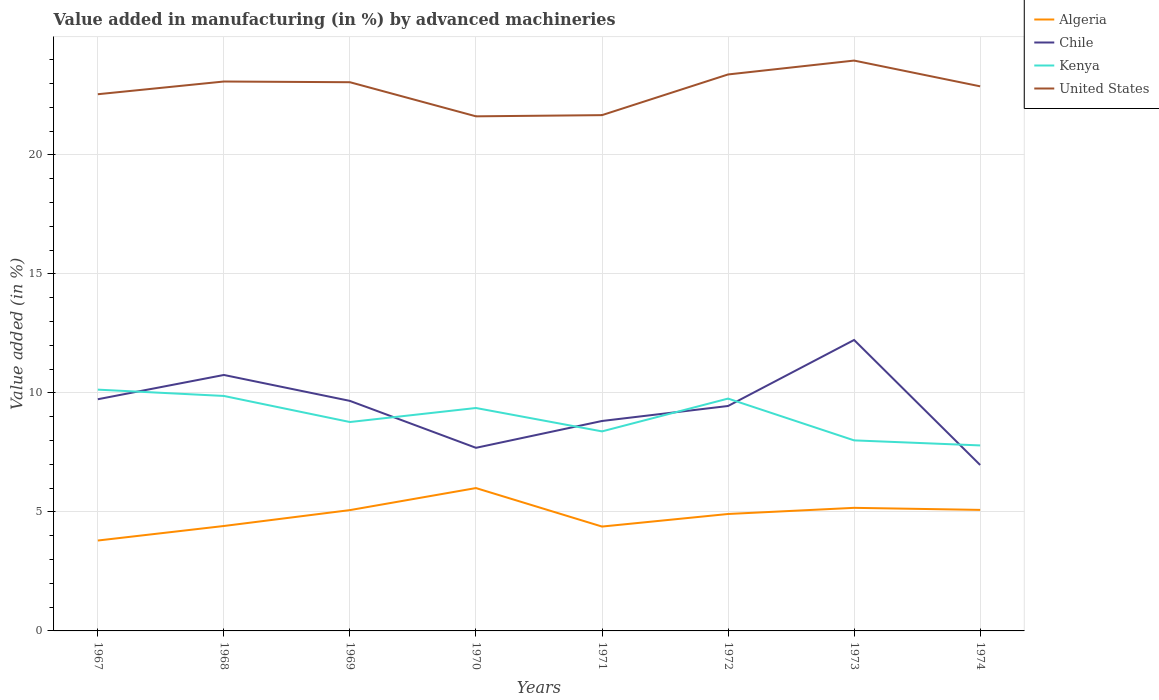How many different coloured lines are there?
Provide a short and direct response. 4. Does the line corresponding to Algeria intersect with the line corresponding to Chile?
Offer a very short reply. No. Across all years, what is the maximum percentage of value added in manufacturing by advanced machineries in United States?
Provide a short and direct response. 21.62. In which year was the percentage of value added in manufacturing by advanced machineries in Kenya maximum?
Provide a short and direct response. 1974. What is the total percentage of value added in manufacturing by advanced machineries in Algeria in the graph?
Make the answer very short. 0.83. What is the difference between the highest and the second highest percentage of value added in manufacturing by advanced machineries in Kenya?
Ensure brevity in your answer.  2.34. How many years are there in the graph?
Your answer should be very brief. 8. What is the difference between two consecutive major ticks on the Y-axis?
Ensure brevity in your answer.  5. Are the values on the major ticks of Y-axis written in scientific E-notation?
Give a very brief answer. No. Does the graph contain any zero values?
Your response must be concise. No. Does the graph contain grids?
Provide a succinct answer. Yes. Where does the legend appear in the graph?
Give a very brief answer. Top right. How many legend labels are there?
Your answer should be very brief. 4. What is the title of the graph?
Ensure brevity in your answer.  Value added in manufacturing (in %) by advanced machineries. Does "Luxembourg" appear as one of the legend labels in the graph?
Provide a short and direct response. No. What is the label or title of the X-axis?
Provide a succinct answer. Years. What is the label or title of the Y-axis?
Offer a terse response. Value added (in %). What is the Value added (in %) of Algeria in 1967?
Ensure brevity in your answer.  3.8. What is the Value added (in %) in Chile in 1967?
Make the answer very short. 9.73. What is the Value added (in %) of Kenya in 1967?
Provide a short and direct response. 10.14. What is the Value added (in %) of United States in 1967?
Provide a succinct answer. 22.55. What is the Value added (in %) in Algeria in 1968?
Keep it short and to the point. 4.41. What is the Value added (in %) of Chile in 1968?
Provide a succinct answer. 10.75. What is the Value added (in %) in Kenya in 1968?
Offer a very short reply. 9.87. What is the Value added (in %) of United States in 1968?
Offer a very short reply. 23.08. What is the Value added (in %) of Algeria in 1969?
Ensure brevity in your answer.  5.08. What is the Value added (in %) in Chile in 1969?
Offer a terse response. 9.66. What is the Value added (in %) in Kenya in 1969?
Your answer should be very brief. 8.78. What is the Value added (in %) in United States in 1969?
Provide a succinct answer. 23.05. What is the Value added (in %) in Algeria in 1970?
Provide a short and direct response. 6. What is the Value added (in %) of Chile in 1970?
Provide a succinct answer. 7.69. What is the Value added (in %) in Kenya in 1970?
Make the answer very short. 9.37. What is the Value added (in %) in United States in 1970?
Ensure brevity in your answer.  21.62. What is the Value added (in %) in Algeria in 1971?
Make the answer very short. 4.38. What is the Value added (in %) of Chile in 1971?
Offer a very short reply. 8.82. What is the Value added (in %) in Kenya in 1971?
Make the answer very short. 8.38. What is the Value added (in %) in United States in 1971?
Provide a succinct answer. 21.67. What is the Value added (in %) in Algeria in 1972?
Offer a terse response. 4.91. What is the Value added (in %) in Chile in 1972?
Provide a short and direct response. 9.45. What is the Value added (in %) of Kenya in 1972?
Your answer should be very brief. 9.76. What is the Value added (in %) of United States in 1972?
Provide a short and direct response. 23.38. What is the Value added (in %) of Algeria in 1973?
Offer a very short reply. 5.17. What is the Value added (in %) in Chile in 1973?
Provide a short and direct response. 12.22. What is the Value added (in %) in Kenya in 1973?
Offer a terse response. 8. What is the Value added (in %) of United States in 1973?
Your answer should be compact. 23.96. What is the Value added (in %) of Algeria in 1974?
Your answer should be very brief. 5.08. What is the Value added (in %) in Chile in 1974?
Offer a terse response. 6.97. What is the Value added (in %) in Kenya in 1974?
Ensure brevity in your answer.  7.79. What is the Value added (in %) of United States in 1974?
Your answer should be compact. 22.88. Across all years, what is the maximum Value added (in %) of Algeria?
Keep it short and to the point. 6. Across all years, what is the maximum Value added (in %) in Chile?
Keep it short and to the point. 12.22. Across all years, what is the maximum Value added (in %) of Kenya?
Give a very brief answer. 10.14. Across all years, what is the maximum Value added (in %) in United States?
Provide a succinct answer. 23.96. Across all years, what is the minimum Value added (in %) in Algeria?
Give a very brief answer. 3.8. Across all years, what is the minimum Value added (in %) of Chile?
Keep it short and to the point. 6.97. Across all years, what is the minimum Value added (in %) in Kenya?
Offer a terse response. 7.79. Across all years, what is the minimum Value added (in %) of United States?
Offer a terse response. 21.62. What is the total Value added (in %) in Algeria in the graph?
Provide a succinct answer. 38.83. What is the total Value added (in %) of Chile in the graph?
Your response must be concise. 75.3. What is the total Value added (in %) of Kenya in the graph?
Your answer should be very brief. 72.09. What is the total Value added (in %) of United States in the graph?
Ensure brevity in your answer.  182.18. What is the difference between the Value added (in %) of Algeria in 1967 and that in 1968?
Your answer should be compact. -0.61. What is the difference between the Value added (in %) in Chile in 1967 and that in 1968?
Provide a short and direct response. -1.02. What is the difference between the Value added (in %) of Kenya in 1967 and that in 1968?
Your response must be concise. 0.27. What is the difference between the Value added (in %) in United States in 1967 and that in 1968?
Give a very brief answer. -0.53. What is the difference between the Value added (in %) of Algeria in 1967 and that in 1969?
Your answer should be very brief. -1.28. What is the difference between the Value added (in %) in Chile in 1967 and that in 1969?
Provide a succinct answer. 0.07. What is the difference between the Value added (in %) of Kenya in 1967 and that in 1969?
Your answer should be very brief. 1.36. What is the difference between the Value added (in %) in United States in 1967 and that in 1969?
Offer a very short reply. -0.5. What is the difference between the Value added (in %) in Algeria in 1967 and that in 1970?
Offer a very short reply. -2.2. What is the difference between the Value added (in %) in Chile in 1967 and that in 1970?
Your answer should be very brief. 2.04. What is the difference between the Value added (in %) in Kenya in 1967 and that in 1970?
Give a very brief answer. 0.77. What is the difference between the Value added (in %) of United States in 1967 and that in 1970?
Your answer should be compact. 0.93. What is the difference between the Value added (in %) of Algeria in 1967 and that in 1971?
Your answer should be very brief. -0.59. What is the difference between the Value added (in %) of Chile in 1967 and that in 1971?
Give a very brief answer. 0.91. What is the difference between the Value added (in %) of Kenya in 1967 and that in 1971?
Offer a very short reply. 1.75. What is the difference between the Value added (in %) of United States in 1967 and that in 1971?
Ensure brevity in your answer.  0.88. What is the difference between the Value added (in %) of Algeria in 1967 and that in 1972?
Your answer should be very brief. -1.11. What is the difference between the Value added (in %) in Chile in 1967 and that in 1972?
Your answer should be very brief. 0.28. What is the difference between the Value added (in %) of Kenya in 1967 and that in 1972?
Keep it short and to the point. 0.38. What is the difference between the Value added (in %) of United States in 1967 and that in 1972?
Provide a succinct answer. -0.83. What is the difference between the Value added (in %) in Algeria in 1967 and that in 1973?
Provide a short and direct response. -1.37. What is the difference between the Value added (in %) of Chile in 1967 and that in 1973?
Provide a short and direct response. -2.49. What is the difference between the Value added (in %) of Kenya in 1967 and that in 1973?
Your answer should be compact. 2.13. What is the difference between the Value added (in %) in United States in 1967 and that in 1973?
Offer a very short reply. -1.41. What is the difference between the Value added (in %) of Algeria in 1967 and that in 1974?
Keep it short and to the point. -1.29. What is the difference between the Value added (in %) in Chile in 1967 and that in 1974?
Give a very brief answer. 2.76. What is the difference between the Value added (in %) in Kenya in 1967 and that in 1974?
Your response must be concise. 2.34. What is the difference between the Value added (in %) in United States in 1967 and that in 1974?
Keep it short and to the point. -0.33. What is the difference between the Value added (in %) in Algeria in 1968 and that in 1969?
Ensure brevity in your answer.  -0.67. What is the difference between the Value added (in %) in Chile in 1968 and that in 1969?
Ensure brevity in your answer.  1.09. What is the difference between the Value added (in %) in Kenya in 1968 and that in 1969?
Your response must be concise. 1.1. What is the difference between the Value added (in %) of United States in 1968 and that in 1969?
Make the answer very short. 0.03. What is the difference between the Value added (in %) in Algeria in 1968 and that in 1970?
Your answer should be very brief. -1.59. What is the difference between the Value added (in %) of Chile in 1968 and that in 1970?
Offer a very short reply. 3.06. What is the difference between the Value added (in %) of Kenya in 1968 and that in 1970?
Your answer should be very brief. 0.51. What is the difference between the Value added (in %) of United States in 1968 and that in 1970?
Your response must be concise. 1.46. What is the difference between the Value added (in %) in Algeria in 1968 and that in 1971?
Give a very brief answer. 0.02. What is the difference between the Value added (in %) in Chile in 1968 and that in 1971?
Give a very brief answer. 1.93. What is the difference between the Value added (in %) of Kenya in 1968 and that in 1971?
Offer a very short reply. 1.49. What is the difference between the Value added (in %) in United States in 1968 and that in 1971?
Your answer should be very brief. 1.41. What is the difference between the Value added (in %) in Algeria in 1968 and that in 1972?
Offer a terse response. -0.5. What is the difference between the Value added (in %) of Chile in 1968 and that in 1972?
Your answer should be very brief. 1.3. What is the difference between the Value added (in %) of Kenya in 1968 and that in 1972?
Your response must be concise. 0.11. What is the difference between the Value added (in %) in United States in 1968 and that in 1972?
Provide a succinct answer. -0.3. What is the difference between the Value added (in %) in Algeria in 1968 and that in 1973?
Offer a very short reply. -0.76. What is the difference between the Value added (in %) of Chile in 1968 and that in 1973?
Give a very brief answer. -1.47. What is the difference between the Value added (in %) in Kenya in 1968 and that in 1973?
Offer a very short reply. 1.87. What is the difference between the Value added (in %) in United States in 1968 and that in 1973?
Your answer should be compact. -0.88. What is the difference between the Value added (in %) of Algeria in 1968 and that in 1974?
Offer a terse response. -0.68. What is the difference between the Value added (in %) of Chile in 1968 and that in 1974?
Ensure brevity in your answer.  3.78. What is the difference between the Value added (in %) of Kenya in 1968 and that in 1974?
Give a very brief answer. 2.08. What is the difference between the Value added (in %) of United States in 1968 and that in 1974?
Offer a very short reply. 0.2. What is the difference between the Value added (in %) of Algeria in 1969 and that in 1970?
Offer a very short reply. -0.93. What is the difference between the Value added (in %) in Chile in 1969 and that in 1970?
Give a very brief answer. 1.97. What is the difference between the Value added (in %) in Kenya in 1969 and that in 1970?
Your response must be concise. -0.59. What is the difference between the Value added (in %) of United States in 1969 and that in 1970?
Provide a succinct answer. 1.43. What is the difference between the Value added (in %) of Algeria in 1969 and that in 1971?
Your answer should be very brief. 0.69. What is the difference between the Value added (in %) in Chile in 1969 and that in 1971?
Keep it short and to the point. 0.84. What is the difference between the Value added (in %) in Kenya in 1969 and that in 1971?
Your answer should be very brief. 0.39. What is the difference between the Value added (in %) of United States in 1969 and that in 1971?
Offer a very short reply. 1.38. What is the difference between the Value added (in %) in Algeria in 1969 and that in 1972?
Offer a very short reply. 0.16. What is the difference between the Value added (in %) in Chile in 1969 and that in 1972?
Your answer should be compact. 0.21. What is the difference between the Value added (in %) in Kenya in 1969 and that in 1972?
Your response must be concise. -0.98. What is the difference between the Value added (in %) in United States in 1969 and that in 1972?
Your response must be concise. -0.33. What is the difference between the Value added (in %) of Algeria in 1969 and that in 1973?
Keep it short and to the point. -0.1. What is the difference between the Value added (in %) of Chile in 1969 and that in 1973?
Make the answer very short. -2.56. What is the difference between the Value added (in %) in Kenya in 1969 and that in 1973?
Offer a terse response. 0.77. What is the difference between the Value added (in %) of United States in 1969 and that in 1973?
Offer a terse response. -0.91. What is the difference between the Value added (in %) of Algeria in 1969 and that in 1974?
Make the answer very short. -0.01. What is the difference between the Value added (in %) of Chile in 1969 and that in 1974?
Offer a very short reply. 2.69. What is the difference between the Value added (in %) in Kenya in 1969 and that in 1974?
Your answer should be compact. 0.98. What is the difference between the Value added (in %) in United States in 1969 and that in 1974?
Your answer should be compact. 0.17. What is the difference between the Value added (in %) of Algeria in 1970 and that in 1971?
Ensure brevity in your answer.  1.62. What is the difference between the Value added (in %) in Chile in 1970 and that in 1971?
Your response must be concise. -1.13. What is the difference between the Value added (in %) in Kenya in 1970 and that in 1971?
Offer a terse response. 0.98. What is the difference between the Value added (in %) in United States in 1970 and that in 1971?
Your answer should be very brief. -0.05. What is the difference between the Value added (in %) of Algeria in 1970 and that in 1972?
Offer a very short reply. 1.09. What is the difference between the Value added (in %) in Chile in 1970 and that in 1972?
Make the answer very short. -1.76. What is the difference between the Value added (in %) of Kenya in 1970 and that in 1972?
Your answer should be compact. -0.4. What is the difference between the Value added (in %) in United States in 1970 and that in 1972?
Your answer should be compact. -1.76. What is the difference between the Value added (in %) of Algeria in 1970 and that in 1973?
Provide a short and direct response. 0.83. What is the difference between the Value added (in %) in Chile in 1970 and that in 1973?
Make the answer very short. -4.53. What is the difference between the Value added (in %) of Kenya in 1970 and that in 1973?
Your response must be concise. 1.36. What is the difference between the Value added (in %) in United States in 1970 and that in 1973?
Provide a succinct answer. -2.34. What is the difference between the Value added (in %) in Algeria in 1970 and that in 1974?
Provide a succinct answer. 0.92. What is the difference between the Value added (in %) in Chile in 1970 and that in 1974?
Provide a succinct answer. 0.72. What is the difference between the Value added (in %) in Kenya in 1970 and that in 1974?
Provide a short and direct response. 1.57. What is the difference between the Value added (in %) in United States in 1970 and that in 1974?
Your answer should be very brief. -1.26. What is the difference between the Value added (in %) in Algeria in 1971 and that in 1972?
Provide a short and direct response. -0.53. What is the difference between the Value added (in %) in Chile in 1971 and that in 1972?
Offer a very short reply. -0.63. What is the difference between the Value added (in %) of Kenya in 1971 and that in 1972?
Offer a terse response. -1.38. What is the difference between the Value added (in %) of United States in 1971 and that in 1972?
Offer a terse response. -1.71. What is the difference between the Value added (in %) in Algeria in 1971 and that in 1973?
Your answer should be very brief. -0.79. What is the difference between the Value added (in %) of Chile in 1971 and that in 1973?
Offer a terse response. -3.4. What is the difference between the Value added (in %) in Kenya in 1971 and that in 1973?
Provide a succinct answer. 0.38. What is the difference between the Value added (in %) of United States in 1971 and that in 1973?
Your response must be concise. -2.29. What is the difference between the Value added (in %) in Algeria in 1971 and that in 1974?
Ensure brevity in your answer.  -0.7. What is the difference between the Value added (in %) of Chile in 1971 and that in 1974?
Offer a very short reply. 1.85. What is the difference between the Value added (in %) of Kenya in 1971 and that in 1974?
Give a very brief answer. 0.59. What is the difference between the Value added (in %) of United States in 1971 and that in 1974?
Provide a short and direct response. -1.21. What is the difference between the Value added (in %) in Algeria in 1972 and that in 1973?
Your answer should be compact. -0.26. What is the difference between the Value added (in %) of Chile in 1972 and that in 1973?
Your response must be concise. -2.77. What is the difference between the Value added (in %) in Kenya in 1972 and that in 1973?
Your answer should be very brief. 1.76. What is the difference between the Value added (in %) of United States in 1972 and that in 1973?
Make the answer very short. -0.58. What is the difference between the Value added (in %) of Algeria in 1972 and that in 1974?
Your response must be concise. -0.17. What is the difference between the Value added (in %) of Chile in 1972 and that in 1974?
Offer a very short reply. 2.48. What is the difference between the Value added (in %) in Kenya in 1972 and that in 1974?
Provide a succinct answer. 1.97. What is the difference between the Value added (in %) in United States in 1972 and that in 1974?
Your answer should be very brief. 0.5. What is the difference between the Value added (in %) of Algeria in 1973 and that in 1974?
Provide a short and direct response. 0.09. What is the difference between the Value added (in %) of Chile in 1973 and that in 1974?
Give a very brief answer. 5.25. What is the difference between the Value added (in %) in Kenya in 1973 and that in 1974?
Provide a succinct answer. 0.21. What is the difference between the Value added (in %) of United States in 1973 and that in 1974?
Ensure brevity in your answer.  1.08. What is the difference between the Value added (in %) of Algeria in 1967 and the Value added (in %) of Chile in 1968?
Offer a very short reply. -6.96. What is the difference between the Value added (in %) of Algeria in 1967 and the Value added (in %) of Kenya in 1968?
Make the answer very short. -6.07. What is the difference between the Value added (in %) of Algeria in 1967 and the Value added (in %) of United States in 1968?
Offer a terse response. -19.28. What is the difference between the Value added (in %) in Chile in 1967 and the Value added (in %) in Kenya in 1968?
Ensure brevity in your answer.  -0.14. What is the difference between the Value added (in %) of Chile in 1967 and the Value added (in %) of United States in 1968?
Offer a terse response. -13.35. What is the difference between the Value added (in %) of Kenya in 1967 and the Value added (in %) of United States in 1968?
Your answer should be very brief. -12.94. What is the difference between the Value added (in %) of Algeria in 1967 and the Value added (in %) of Chile in 1969?
Offer a very short reply. -5.87. What is the difference between the Value added (in %) of Algeria in 1967 and the Value added (in %) of Kenya in 1969?
Make the answer very short. -4.98. What is the difference between the Value added (in %) in Algeria in 1967 and the Value added (in %) in United States in 1969?
Offer a terse response. -19.25. What is the difference between the Value added (in %) of Chile in 1967 and the Value added (in %) of Kenya in 1969?
Give a very brief answer. 0.96. What is the difference between the Value added (in %) of Chile in 1967 and the Value added (in %) of United States in 1969?
Your response must be concise. -13.32. What is the difference between the Value added (in %) of Kenya in 1967 and the Value added (in %) of United States in 1969?
Offer a terse response. -12.91. What is the difference between the Value added (in %) in Algeria in 1967 and the Value added (in %) in Chile in 1970?
Offer a very short reply. -3.89. What is the difference between the Value added (in %) in Algeria in 1967 and the Value added (in %) in Kenya in 1970?
Your response must be concise. -5.57. What is the difference between the Value added (in %) of Algeria in 1967 and the Value added (in %) of United States in 1970?
Ensure brevity in your answer.  -17.82. What is the difference between the Value added (in %) in Chile in 1967 and the Value added (in %) in Kenya in 1970?
Keep it short and to the point. 0.37. What is the difference between the Value added (in %) in Chile in 1967 and the Value added (in %) in United States in 1970?
Keep it short and to the point. -11.88. What is the difference between the Value added (in %) in Kenya in 1967 and the Value added (in %) in United States in 1970?
Provide a succinct answer. -11.48. What is the difference between the Value added (in %) in Algeria in 1967 and the Value added (in %) in Chile in 1971?
Your answer should be very brief. -5.02. What is the difference between the Value added (in %) in Algeria in 1967 and the Value added (in %) in Kenya in 1971?
Provide a succinct answer. -4.58. What is the difference between the Value added (in %) in Algeria in 1967 and the Value added (in %) in United States in 1971?
Offer a very short reply. -17.87. What is the difference between the Value added (in %) in Chile in 1967 and the Value added (in %) in Kenya in 1971?
Provide a short and direct response. 1.35. What is the difference between the Value added (in %) of Chile in 1967 and the Value added (in %) of United States in 1971?
Your answer should be compact. -11.93. What is the difference between the Value added (in %) in Kenya in 1967 and the Value added (in %) in United States in 1971?
Provide a succinct answer. -11.53. What is the difference between the Value added (in %) of Algeria in 1967 and the Value added (in %) of Chile in 1972?
Offer a terse response. -5.65. What is the difference between the Value added (in %) of Algeria in 1967 and the Value added (in %) of Kenya in 1972?
Your answer should be compact. -5.96. What is the difference between the Value added (in %) in Algeria in 1967 and the Value added (in %) in United States in 1972?
Offer a very short reply. -19.58. What is the difference between the Value added (in %) of Chile in 1967 and the Value added (in %) of Kenya in 1972?
Offer a very short reply. -0.03. What is the difference between the Value added (in %) of Chile in 1967 and the Value added (in %) of United States in 1972?
Your answer should be very brief. -13.64. What is the difference between the Value added (in %) in Kenya in 1967 and the Value added (in %) in United States in 1972?
Ensure brevity in your answer.  -13.24. What is the difference between the Value added (in %) in Algeria in 1967 and the Value added (in %) in Chile in 1973?
Provide a succinct answer. -8.43. What is the difference between the Value added (in %) in Algeria in 1967 and the Value added (in %) in Kenya in 1973?
Provide a short and direct response. -4.21. What is the difference between the Value added (in %) of Algeria in 1967 and the Value added (in %) of United States in 1973?
Your answer should be compact. -20.16. What is the difference between the Value added (in %) in Chile in 1967 and the Value added (in %) in Kenya in 1973?
Ensure brevity in your answer.  1.73. What is the difference between the Value added (in %) of Chile in 1967 and the Value added (in %) of United States in 1973?
Ensure brevity in your answer.  -14.23. What is the difference between the Value added (in %) of Kenya in 1967 and the Value added (in %) of United States in 1973?
Provide a succinct answer. -13.82. What is the difference between the Value added (in %) of Algeria in 1967 and the Value added (in %) of Chile in 1974?
Offer a very short reply. -3.17. What is the difference between the Value added (in %) of Algeria in 1967 and the Value added (in %) of Kenya in 1974?
Your answer should be very brief. -4. What is the difference between the Value added (in %) of Algeria in 1967 and the Value added (in %) of United States in 1974?
Your answer should be very brief. -19.08. What is the difference between the Value added (in %) in Chile in 1967 and the Value added (in %) in Kenya in 1974?
Give a very brief answer. 1.94. What is the difference between the Value added (in %) in Chile in 1967 and the Value added (in %) in United States in 1974?
Offer a very short reply. -13.15. What is the difference between the Value added (in %) of Kenya in 1967 and the Value added (in %) of United States in 1974?
Offer a terse response. -12.74. What is the difference between the Value added (in %) of Algeria in 1968 and the Value added (in %) of Chile in 1969?
Your answer should be very brief. -5.26. What is the difference between the Value added (in %) in Algeria in 1968 and the Value added (in %) in Kenya in 1969?
Give a very brief answer. -4.37. What is the difference between the Value added (in %) of Algeria in 1968 and the Value added (in %) of United States in 1969?
Your answer should be compact. -18.64. What is the difference between the Value added (in %) of Chile in 1968 and the Value added (in %) of Kenya in 1969?
Offer a terse response. 1.98. What is the difference between the Value added (in %) in Chile in 1968 and the Value added (in %) in United States in 1969?
Give a very brief answer. -12.3. What is the difference between the Value added (in %) of Kenya in 1968 and the Value added (in %) of United States in 1969?
Offer a very short reply. -13.18. What is the difference between the Value added (in %) of Algeria in 1968 and the Value added (in %) of Chile in 1970?
Offer a terse response. -3.28. What is the difference between the Value added (in %) of Algeria in 1968 and the Value added (in %) of Kenya in 1970?
Offer a very short reply. -4.96. What is the difference between the Value added (in %) of Algeria in 1968 and the Value added (in %) of United States in 1970?
Provide a short and direct response. -17.21. What is the difference between the Value added (in %) in Chile in 1968 and the Value added (in %) in Kenya in 1970?
Offer a very short reply. 1.39. What is the difference between the Value added (in %) of Chile in 1968 and the Value added (in %) of United States in 1970?
Ensure brevity in your answer.  -10.87. What is the difference between the Value added (in %) in Kenya in 1968 and the Value added (in %) in United States in 1970?
Your answer should be very brief. -11.75. What is the difference between the Value added (in %) in Algeria in 1968 and the Value added (in %) in Chile in 1971?
Your answer should be compact. -4.41. What is the difference between the Value added (in %) in Algeria in 1968 and the Value added (in %) in Kenya in 1971?
Give a very brief answer. -3.97. What is the difference between the Value added (in %) in Algeria in 1968 and the Value added (in %) in United States in 1971?
Ensure brevity in your answer.  -17.26. What is the difference between the Value added (in %) in Chile in 1968 and the Value added (in %) in Kenya in 1971?
Give a very brief answer. 2.37. What is the difference between the Value added (in %) in Chile in 1968 and the Value added (in %) in United States in 1971?
Keep it short and to the point. -10.92. What is the difference between the Value added (in %) in Kenya in 1968 and the Value added (in %) in United States in 1971?
Your answer should be compact. -11.8. What is the difference between the Value added (in %) of Algeria in 1968 and the Value added (in %) of Chile in 1972?
Give a very brief answer. -5.04. What is the difference between the Value added (in %) of Algeria in 1968 and the Value added (in %) of Kenya in 1972?
Ensure brevity in your answer.  -5.35. What is the difference between the Value added (in %) of Algeria in 1968 and the Value added (in %) of United States in 1972?
Keep it short and to the point. -18.97. What is the difference between the Value added (in %) of Chile in 1968 and the Value added (in %) of United States in 1972?
Provide a succinct answer. -12.62. What is the difference between the Value added (in %) of Kenya in 1968 and the Value added (in %) of United States in 1972?
Provide a short and direct response. -13.51. What is the difference between the Value added (in %) in Algeria in 1968 and the Value added (in %) in Chile in 1973?
Your answer should be very brief. -7.81. What is the difference between the Value added (in %) in Algeria in 1968 and the Value added (in %) in Kenya in 1973?
Your answer should be compact. -3.6. What is the difference between the Value added (in %) of Algeria in 1968 and the Value added (in %) of United States in 1973?
Ensure brevity in your answer.  -19.55. What is the difference between the Value added (in %) in Chile in 1968 and the Value added (in %) in Kenya in 1973?
Provide a short and direct response. 2.75. What is the difference between the Value added (in %) in Chile in 1968 and the Value added (in %) in United States in 1973?
Offer a very short reply. -13.21. What is the difference between the Value added (in %) of Kenya in 1968 and the Value added (in %) of United States in 1973?
Keep it short and to the point. -14.09. What is the difference between the Value added (in %) in Algeria in 1968 and the Value added (in %) in Chile in 1974?
Make the answer very short. -2.56. What is the difference between the Value added (in %) in Algeria in 1968 and the Value added (in %) in Kenya in 1974?
Provide a succinct answer. -3.38. What is the difference between the Value added (in %) in Algeria in 1968 and the Value added (in %) in United States in 1974?
Keep it short and to the point. -18.47. What is the difference between the Value added (in %) in Chile in 1968 and the Value added (in %) in Kenya in 1974?
Provide a short and direct response. 2.96. What is the difference between the Value added (in %) in Chile in 1968 and the Value added (in %) in United States in 1974?
Keep it short and to the point. -12.13. What is the difference between the Value added (in %) in Kenya in 1968 and the Value added (in %) in United States in 1974?
Offer a terse response. -13.01. What is the difference between the Value added (in %) in Algeria in 1969 and the Value added (in %) in Chile in 1970?
Ensure brevity in your answer.  -2.62. What is the difference between the Value added (in %) of Algeria in 1969 and the Value added (in %) of Kenya in 1970?
Keep it short and to the point. -4.29. What is the difference between the Value added (in %) in Algeria in 1969 and the Value added (in %) in United States in 1970?
Provide a short and direct response. -16.54. What is the difference between the Value added (in %) in Chile in 1969 and the Value added (in %) in Kenya in 1970?
Your answer should be compact. 0.3. What is the difference between the Value added (in %) in Chile in 1969 and the Value added (in %) in United States in 1970?
Keep it short and to the point. -11.95. What is the difference between the Value added (in %) of Kenya in 1969 and the Value added (in %) of United States in 1970?
Offer a terse response. -12.84. What is the difference between the Value added (in %) of Algeria in 1969 and the Value added (in %) of Chile in 1971?
Make the answer very short. -3.74. What is the difference between the Value added (in %) of Algeria in 1969 and the Value added (in %) of Kenya in 1971?
Provide a succinct answer. -3.31. What is the difference between the Value added (in %) of Algeria in 1969 and the Value added (in %) of United States in 1971?
Provide a succinct answer. -16.59. What is the difference between the Value added (in %) in Chile in 1969 and the Value added (in %) in Kenya in 1971?
Offer a very short reply. 1.28. What is the difference between the Value added (in %) of Chile in 1969 and the Value added (in %) of United States in 1971?
Provide a short and direct response. -12. What is the difference between the Value added (in %) in Kenya in 1969 and the Value added (in %) in United States in 1971?
Make the answer very short. -12.89. What is the difference between the Value added (in %) of Algeria in 1969 and the Value added (in %) of Chile in 1972?
Keep it short and to the point. -4.37. What is the difference between the Value added (in %) in Algeria in 1969 and the Value added (in %) in Kenya in 1972?
Keep it short and to the point. -4.68. What is the difference between the Value added (in %) in Algeria in 1969 and the Value added (in %) in United States in 1972?
Provide a succinct answer. -18.3. What is the difference between the Value added (in %) of Chile in 1969 and the Value added (in %) of Kenya in 1972?
Your response must be concise. -0.1. What is the difference between the Value added (in %) of Chile in 1969 and the Value added (in %) of United States in 1972?
Your response must be concise. -13.71. What is the difference between the Value added (in %) of Kenya in 1969 and the Value added (in %) of United States in 1972?
Keep it short and to the point. -14.6. What is the difference between the Value added (in %) of Algeria in 1969 and the Value added (in %) of Chile in 1973?
Provide a succinct answer. -7.15. What is the difference between the Value added (in %) in Algeria in 1969 and the Value added (in %) in Kenya in 1973?
Give a very brief answer. -2.93. What is the difference between the Value added (in %) in Algeria in 1969 and the Value added (in %) in United States in 1973?
Make the answer very short. -18.88. What is the difference between the Value added (in %) in Chile in 1969 and the Value added (in %) in Kenya in 1973?
Provide a short and direct response. 1.66. What is the difference between the Value added (in %) in Chile in 1969 and the Value added (in %) in United States in 1973?
Keep it short and to the point. -14.3. What is the difference between the Value added (in %) of Kenya in 1969 and the Value added (in %) of United States in 1973?
Your answer should be very brief. -15.18. What is the difference between the Value added (in %) in Algeria in 1969 and the Value added (in %) in Chile in 1974?
Ensure brevity in your answer.  -1.9. What is the difference between the Value added (in %) in Algeria in 1969 and the Value added (in %) in Kenya in 1974?
Offer a very short reply. -2.72. What is the difference between the Value added (in %) of Algeria in 1969 and the Value added (in %) of United States in 1974?
Offer a very short reply. -17.8. What is the difference between the Value added (in %) of Chile in 1969 and the Value added (in %) of Kenya in 1974?
Your answer should be compact. 1.87. What is the difference between the Value added (in %) in Chile in 1969 and the Value added (in %) in United States in 1974?
Make the answer very short. -13.21. What is the difference between the Value added (in %) of Kenya in 1969 and the Value added (in %) of United States in 1974?
Your answer should be compact. -14.1. What is the difference between the Value added (in %) of Algeria in 1970 and the Value added (in %) of Chile in 1971?
Give a very brief answer. -2.82. What is the difference between the Value added (in %) of Algeria in 1970 and the Value added (in %) of Kenya in 1971?
Your response must be concise. -2.38. What is the difference between the Value added (in %) in Algeria in 1970 and the Value added (in %) in United States in 1971?
Your answer should be very brief. -15.67. What is the difference between the Value added (in %) of Chile in 1970 and the Value added (in %) of Kenya in 1971?
Provide a short and direct response. -0.69. What is the difference between the Value added (in %) of Chile in 1970 and the Value added (in %) of United States in 1971?
Ensure brevity in your answer.  -13.98. What is the difference between the Value added (in %) of Kenya in 1970 and the Value added (in %) of United States in 1971?
Make the answer very short. -12.3. What is the difference between the Value added (in %) of Algeria in 1970 and the Value added (in %) of Chile in 1972?
Your answer should be compact. -3.45. What is the difference between the Value added (in %) of Algeria in 1970 and the Value added (in %) of Kenya in 1972?
Your response must be concise. -3.76. What is the difference between the Value added (in %) in Algeria in 1970 and the Value added (in %) in United States in 1972?
Provide a short and direct response. -17.38. What is the difference between the Value added (in %) of Chile in 1970 and the Value added (in %) of Kenya in 1972?
Offer a very short reply. -2.07. What is the difference between the Value added (in %) in Chile in 1970 and the Value added (in %) in United States in 1972?
Your answer should be compact. -15.68. What is the difference between the Value added (in %) of Kenya in 1970 and the Value added (in %) of United States in 1972?
Your answer should be very brief. -14.01. What is the difference between the Value added (in %) in Algeria in 1970 and the Value added (in %) in Chile in 1973?
Provide a short and direct response. -6.22. What is the difference between the Value added (in %) of Algeria in 1970 and the Value added (in %) of Kenya in 1973?
Keep it short and to the point. -2. What is the difference between the Value added (in %) in Algeria in 1970 and the Value added (in %) in United States in 1973?
Your answer should be very brief. -17.96. What is the difference between the Value added (in %) of Chile in 1970 and the Value added (in %) of Kenya in 1973?
Keep it short and to the point. -0.31. What is the difference between the Value added (in %) of Chile in 1970 and the Value added (in %) of United States in 1973?
Offer a very short reply. -16.27. What is the difference between the Value added (in %) of Kenya in 1970 and the Value added (in %) of United States in 1973?
Ensure brevity in your answer.  -14.6. What is the difference between the Value added (in %) in Algeria in 1970 and the Value added (in %) in Chile in 1974?
Provide a short and direct response. -0.97. What is the difference between the Value added (in %) of Algeria in 1970 and the Value added (in %) of Kenya in 1974?
Offer a terse response. -1.79. What is the difference between the Value added (in %) of Algeria in 1970 and the Value added (in %) of United States in 1974?
Provide a short and direct response. -16.88. What is the difference between the Value added (in %) in Chile in 1970 and the Value added (in %) in Kenya in 1974?
Your answer should be compact. -0.1. What is the difference between the Value added (in %) of Chile in 1970 and the Value added (in %) of United States in 1974?
Your answer should be very brief. -15.19. What is the difference between the Value added (in %) in Kenya in 1970 and the Value added (in %) in United States in 1974?
Your answer should be compact. -13.51. What is the difference between the Value added (in %) in Algeria in 1971 and the Value added (in %) in Chile in 1972?
Ensure brevity in your answer.  -5.07. What is the difference between the Value added (in %) of Algeria in 1971 and the Value added (in %) of Kenya in 1972?
Provide a short and direct response. -5.38. What is the difference between the Value added (in %) of Algeria in 1971 and the Value added (in %) of United States in 1972?
Keep it short and to the point. -18.99. What is the difference between the Value added (in %) of Chile in 1971 and the Value added (in %) of Kenya in 1972?
Offer a terse response. -0.94. What is the difference between the Value added (in %) in Chile in 1971 and the Value added (in %) in United States in 1972?
Your answer should be very brief. -14.56. What is the difference between the Value added (in %) of Kenya in 1971 and the Value added (in %) of United States in 1972?
Your answer should be very brief. -14.99. What is the difference between the Value added (in %) in Algeria in 1971 and the Value added (in %) in Chile in 1973?
Keep it short and to the point. -7.84. What is the difference between the Value added (in %) of Algeria in 1971 and the Value added (in %) of Kenya in 1973?
Offer a terse response. -3.62. What is the difference between the Value added (in %) of Algeria in 1971 and the Value added (in %) of United States in 1973?
Provide a short and direct response. -19.58. What is the difference between the Value added (in %) in Chile in 1971 and the Value added (in %) in Kenya in 1973?
Offer a very short reply. 0.81. What is the difference between the Value added (in %) of Chile in 1971 and the Value added (in %) of United States in 1973?
Provide a succinct answer. -15.14. What is the difference between the Value added (in %) in Kenya in 1971 and the Value added (in %) in United States in 1973?
Your answer should be compact. -15.58. What is the difference between the Value added (in %) in Algeria in 1971 and the Value added (in %) in Chile in 1974?
Your answer should be very brief. -2.59. What is the difference between the Value added (in %) of Algeria in 1971 and the Value added (in %) of Kenya in 1974?
Ensure brevity in your answer.  -3.41. What is the difference between the Value added (in %) of Algeria in 1971 and the Value added (in %) of United States in 1974?
Offer a very short reply. -18.49. What is the difference between the Value added (in %) in Chile in 1971 and the Value added (in %) in Kenya in 1974?
Keep it short and to the point. 1.03. What is the difference between the Value added (in %) in Chile in 1971 and the Value added (in %) in United States in 1974?
Make the answer very short. -14.06. What is the difference between the Value added (in %) of Kenya in 1971 and the Value added (in %) of United States in 1974?
Your answer should be very brief. -14.5. What is the difference between the Value added (in %) of Algeria in 1972 and the Value added (in %) of Chile in 1973?
Your answer should be very brief. -7.31. What is the difference between the Value added (in %) in Algeria in 1972 and the Value added (in %) in Kenya in 1973?
Give a very brief answer. -3.09. What is the difference between the Value added (in %) of Algeria in 1972 and the Value added (in %) of United States in 1973?
Make the answer very short. -19.05. What is the difference between the Value added (in %) in Chile in 1972 and the Value added (in %) in Kenya in 1973?
Offer a terse response. 1.44. What is the difference between the Value added (in %) of Chile in 1972 and the Value added (in %) of United States in 1973?
Provide a succinct answer. -14.51. What is the difference between the Value added (in %) in Kenya in 1972 and the Value added (in %) in United States in 1973?
Make the answer very short. -14.2. What is the difference between the Value added (in %) in Algeria in 1972 and the Value added (in %) in Chile in 1974?
Ensure brevity in your answer.  -2.06. What is the difference between the Value added (in %) in Algeria in 1972 and the Value added (in %) in Kenya in 1974?
Give a very brief answer. -2.88. What is the difference between the Value added (in %) of Algeria in 1972 and the Value added (in %) of United States in 1974?
Give a very brief answer. -17.97. What is the difference between the Value added (in %) of Chile in 1972 and the Value added (in %) of Kenya in 1974?
Offer a terse response. 1.66. What is the difference between the Value added (in %) in Chile in 1972 and the Value added (in %) in United States in 1974?
Offer a very short reply. -13.43. What is the difference between the Value added (in %) of Kenya in 1972 and the Value added (in %) of United States in 1974?
Give a very brief answer. -13.12. What is the difference between the Value added (in %) of Algeria in 1973 and the Value added (in %) of Chile in 1974?
Offer a very short reply. -1.8. What is the difference between the Value added (in %) of Algeria in 1973 and the Value added (in %) of Kenya in 1974?
Keep it short and to the point. -2.62. What is the difference between the Value added (in %) of Algeria in 1973 and the Value added (in %) of United States in 1974?
Give a very brief answer. -17.71. What is the difference between the Value added (in %) in Chile in 1973 and the Value added (in %) in Kenya in 1974?
Your answer should be compact. 4.43. What is the difference between the Value added (in %) in Chile in 1973 and the Value added (in %) in United States in 1974?
Offer a terse response. -10.66. What is the difference between the Value added (in %) in Kenya in 1973 and the Value added (in %) in United States in 1974?
Offer a terse response. -14.87. What is the average Value added (in %) of Algeria per year?
Your answer should be very brief. 4.85. What is the average Value added (in %) of Chile per year?
Your answer should be compact. 9.41. What is the average Value added (in %) in Kenya per year?
Your answer should be very brief. 9.01. What is the average Value added (in %) in United States per year?
Provide a succinct answer. 22.77. In the year 1967, what is the difference between the Value added (in %) of Algeria and Value added (in %) of Chile?
Ensure brevity in your answer.  -5.94. In the year 1967, what is the difference between the Value added (in %) of Algeria and Value added (in %) of Kenya?
Provide a short and direct response. -6.34. In the year 1967, what is the difference between the Value added (in %) of Algeria and Value added (in %) of United States?
Provide a short and direct response. -18.75. In the year 1967, what is the difference between the Value added (in %) in Chile and Value added (in %) in Kenya?
Offer a very short reply. -0.4. In the year 1967, what is the difference between the Value added (in %) of Chile and Value added (in %) of United States?
Your answer should be compact. -12.81. In the year 1967, what is the difference between the Value added (in %) in Kenya and Value added (in %) in United States?
Give a very brief answer. -12.41. In the year 1968, what is the difference between the Value added (in %) in Algeria and Value added (in %) in Chile?
Keep it short and to the point. -6.34. In the year 1968, what is the difference between the Value added (in %) in Algeria and Value added (in %) in Kenya?
Your answer should be compact. -5.46. In the year 1968, what is the difference between the Value added (in %) in Algeria and Value added (in %) in United States?
Make the answer very short. -18.67. In the year 1968, what is the difference between the Value added (in %) in Chile and Value added (in %) in Kenya?
Your answer should be very brief. 0.88. In the year 1968, what is the difference between the Value added (in %) in Chile and Value added (in %) in United States?
Provide a succinct answer. -12.33. In the year 1968, what is the difference between the Value added (in %) in Kenya and Value added (in %) in United States?
Your answer should be very brief. -13.21. In the year 1969, what is the difference between the Value added (in %) in Algeria and Value added (in %) in Chile?
Give a very brief answer. -4.59. In the year 1969, what is the difference between the Value added (in %) in Algeria and Value added (in %) in Kenya?
Keep it short and to the point. -3.7. In the year 1969, what is the difference between the Value added (in %) in Algeria and Value added (in %) in United States?
Offer a terse response. -17.98. In the year 1969, what is the difference between the Value added (in %) in Chile and Value added (in %) in Kenya?
Provide a succinct answer. 0.89. In the year 1969, what is the difference between the Value added (in %) in Chile and Value added (in %) in United States?
Make the answer very short. -13.39. In the year 1969, what is the difference between the Value added (in %) in Kenya and Value added (in %) in United States?
Provide a succinct answer. -14.28. In the year 1970, what is the difference between the Value added (in %) of Algeria and Value added (in %) of Chile?
Ensure brevity in your answer.  -1.69. In the year 1970, what is the difference between the Value added (in %) of Algeria and Value added (in %) of Kenya?
Your answer should be very brief. -3.36. In the year 1970, what is the difference between the Value added (in %) of Algeria and Value added (in %) of United States?
Your answer should be very brief. -15.62. In the year 1970, what is the difference between the Value added (in %) in Chile and Value added (in %) in Kenya?
Offer a terse response. -1.67. In the year 1970, what is the difference between the Value added (in %) of Chile and Value added (in %) of United States?
Ensure brevity in your answer.  -13.93. In the year 1970, what is the difference between the Value added (in %) in Kenya and Value added (in %) in United States?
Ensure brevity in your answer.  -12.25. In the year 1971, what is the difference between the Value added (in %) in Algeria and Value added (in %) in Chile?
Provide a succinct answer. -4.44. In the year 1971, what is the difference between the Value added (in %) in Algeria and Value added (in %) in Kenya?
Your response must be concise. -4. In the year 1971, what is the difference between the Value added (in %) of Algeria and Value added (in %) of United States?
Provide a short and direct response. -17.28. In the year 1971, what is the difference between the Value added (in %) of Chile and Value added (in %) of Kenya?
Offer a terse response. 0.44. In the year 1971, what is the difference between the Value added (in %) in Chile and Value added (in %) in United States?
Your answer should be very brief. -12.85. In the year 1971, what is the difference between the Value added (in %) in Kenya and Value added (in %) in United States?
Offer a very short reply. -13.29. In the year 1972, what is the difference between the Value added (in %) in Algeria and Value added (in %) in Chile?
Provide a short and direct response. -4.54. In the year 1972, what is the difference between the Value added (in %) of Algeria and Value added (in %) of Kenya?
Your response must be concise. -4.85. In the year 1972, what is the difference between the Value added (in %) in Algeria and Value added (in %) in United States?
Offer a terse response. -18.46. In the year 1972, what is the difference between the Value added (in %) of Chile and Value added (in %) of Kenya?
Provide a succinct answer. -0.31. In the year 1972, what is the difference between the Value added (in %) of Chile and Value added (in %) of United States?
Offer a terse response. -13.93. In the year 1972, what is the difference between the Value added (in %) in Kenya and Value added (in %) in United States?
Ensure brevity in your answer.  -13.62. In the year 1973, what is the difference between the Value added (in %) in Algeria and Value added (in %) in Chile?
Make the answer very short. -7.05. In the year 1973, what is the difference between the Value added (in %) of Algeria and Value added (in %) of Kenya?
Your answer should be very brief. -2.83. In the year 1973, what is the difference between the Value added (in %) in Algeria and Value added (in %) in United States?
Offer a terse response. -18.79. In the year 1973, what is the difference between the Value added (in %) in Chile and Value added (in %) in Kenya?
Your answer should be very brief. 4.22. In the year 1973, what is the difference between the Value added (in %) of Chile and Value added (in %) of United States?
Ensure brevity in your answer.  -11.74. In the year 1973, what is the difference between the Value added (in %) of Kenya and Value added (in %) of United States?
Make the answer very short. -15.96. In the year 1974, what is the difference between the Value added (in %) in Algeria and Value added (in %) in Chile?
Ensure brevity in your answer.  -1.89. In the year 1974, what is the difference between the Value added (in %) in Algeria and Value added (in %) in Kenya?
Offer a terse response. -2.71. In the year 1974, what is the difference between the Value added (in %) in Algeria and Value added (in %) in United States?
Provide a short and direct response. -17.79. In the year 1974, what is the difference between the Value added (in %) in Chile and Value added (in %) in Kenya?
Your answer should be very brief. -0.82. In the year 1974, what is the difference between the Value added (in %) in Chile and Value added (in %) in United States?
Ensure brevity in your answer.  -15.91. In the year 1974, what is the difference between the Value added (in %) in Kenya and Value added (in %) in United States?
Your response must be concise. -15.09. What is the ratio of the Value added (in %) in Algeria in 1967 to that in 1968?
Keep it short and to the point. 0.86. What is the ratio of the Value added (in %) in Chile in 1967 to that in 1968?
Offer a terse response. 0.91. What is the ratio of the Value added (in %) in Kenya in 1967 to that in 1968?
Ensure brevity in your answer.  1.03. What is the ratio of the Value added (in %) of United States in 1967 to that in 1968?
Make the answer very short. 0.98. What is the ratio of the Value added (in %) in Algeria in 1967 to that in 1969?
Offer a very short reply. 0.75. What is the ratio of the Value added (in %) in Kenya in 1967 to that in 1969?
Make the answer very short. 1.16. What is the ratio of the Value added (in %) of United States in 1967 to that in 1969?
Make the answer very short. 0.98. What is the ratio of the Value added (in %) of Algeria in 1967 to that in 1970?
Your response must be concise. 0.63. What is the ratio of the Value added (in %) of Chile in 1967 to that in 1970?
Offer a very short reply. 1.27. What is the ratio of the Value added (in %) in Kenya in 1967 to that in 1970?
Keep it short and to the point. 1.08. What is the ratio of the Value added (in %) of United States in 1967 to that in 1970?
Your answer should be very brief. 1.04. What is the ratio of the Value added (in %) in Algeria in 1967 to that in 1971?
Ensure brevity in your answer.  0.87. What is the ratio of the Value added (in %) in Chile in 1967 to that in 1971?
Provide a short and direct response. 1.1. What is the ratio of the Value added (in %) of Kenya in 1967 to that in 1971?
Give a very brief answer. 1.21. What is the ratio of the Value added (in %) in United States in 1967 to that in 1971?
Provide a short and direct response. 1.04. What is the ratio of the Value added (in %) in Algeria in 1967 to that in 1972?
Make the answer very short. 0.77. What is the ratio of the Value added (in %) of Chile in 1967 to that in 1972?
Provide a succinct answer. 1.03. What is the ratio of the Value added (in %) of Kenya in 1967 to that in 1972?
Your answer should be very brief. 1.04. What is the ratio of the Value added (in %) of United States in 1967 to that in 1972?
Your response must be concise. 0.96. What is the ratio of the Value added (in %) in Algeria in 1967 to that in 1973?
Offer a terse response. 0.73. What is the ratio of the Value added (in %) of Chile in 1967 to that in 1973?
Your response must be concise. 0.8. What is the ratio of the Value added (in %) in Kenya in 1967 to that in 1973?
Make the answer very short. 1.27. What is the ratio of the Value added (in %) in United States in 1967 to that in 1973?
Offer a terse response. 0.94. What is the ratio of the Value added (in %) in Algeria in 1967 to that in 1974?
Provide a short and direct response. 0.75. What is the ratio of the Value added (in %) in Chile in 1967 to that in 1974?
Keep it short and to the point. 1.4. What is the ratio of the Value added (in %) of Kenya in 1967 to that in 1974?
Make the answer very short. 1.3. What is the ratio of the Value added (in %) in United States in 1967 to that in 1974?
Offer a terse response. 0.99. What is the ratio of the Value added (in %) in Algeria in 1968 to that in 1969?
Your response must be concise. 0.87. What is the ratio of the Value added (in %) of Chile in 1968 to that in 1969?
Offer a very short reply. 1.11. What is the ratio of the Value added (in %) of Kenya in 1968 to that in 1969?
Your answer should be very brief. 1.12. What is the ratio of the Value added (in %) of Algeria in 1968 to that in 1970?
Your answer should be compact. 0.73. What is the ratio of the Value added (in %) of Chile in 1968 to that in 1970?
Your response must be concise. 1.4. What is the ratio of the Value added (in %) in Kenya in 1968 to that in 1970?
Your response must be concise. 1.05. What is the ratio of the Value added (in %) in United States in 1968 to that in 1970?
Make the answer very short. 1.07. What is the ratio of the Value added (in %) in Algeria in 1968 to that in 1971?
Offer a very short reply. 1.01. What is the ratio of the Value added (in %) of Chile in 1968 to that in 1971?
Ensure brevity in your answer.  1.22. What is the ratio of the Value added (in %) in Kenya in 1968 to that in 1971?
Keep it short and to the point. 1.18. What is the ratio of the Value added (in %) in United States in 1968 to that in 1971?
Ensure brevity in your answer.  1.07. What is the ratio of the Value added (in %) of Algeria in 1968 to that in 1972?
Keep it short and to the point. 0.9. What is the ratio of the Value added (in %) in Chile in 1968 to that in 1972?
Your answer should be very brief. 1.14. What is the ratio of the Value added (in %) in Kenya in 1968 to that in 1972?
Your answer should be very brief. 1.01. What is the ratio of the Value added (in %) in United States in 1968 to that in 1972?
Keep it short and to the point. 0.99. What is the ratio of the Value added (in %) in Algeria in 1968 to that in 1973?
Your response must be concise. 0.85. What is the ratio of the Value added (in %) of Chile in 1968 to that in 1973?
Ensure brevity in your answer.  0.88. What is the ratio of the Value added (in %) in Kenya in 1968 to that in 1973?
Provide a short and direct response. 1.23. What is the ratio of the Value added (in %) in United States in 1968 to that in 1973?
Give a very brief answer. 0.96. What is the ratio of the Value added (in %) in Algeria in 1968 to that in 1974?
Offer a very short reply. 0.87. What is the ratio of the Value added (in %) in Chile in 1968 to that in 1974?
Provide a succinct answer. 1.54. What is the ratio of the Value added (in %) in Kenya in 1968 to that in 1974?
Provide a succinct answer. 1.27. What is the ratio of the Value added (in %) of United States in 1968 to that in 1974?
Offer a terse response. 1.01. What is the ratio of the Value added (in %) of Algeria in 1969 to that in 1970?
Your response must be concise. 0.85. What is the ratio of the Value added (in %) of Chile in 1969 to that in 1970?
Give a very brief answer. 1.26. What is the ratio of the Value added (in %) in Kenya in 1969 to that in 1970?
Offer a terse response. 0.94. What is the ratio of the Value added (in %) of United States in 1969 to that in 1970?
Give a very brief answer. 1.07. What is the ratio of the Value added (in %) in Algeria in 1969 to that in 1971?
Ensure brevity in your answer.  1.16. What is the ratio of the Value added (in %) of Chile in 1969 to that in 1971?
Ensure brevity in your answer.  1.1. What is the ratio of the Value added (in %) of Kenya in 1969 to that in 1971?
Offer a terse response. 1.05. What is the ratio of the Value added (in %) in United States in 1969 to that in 1971?
Your answer should be very brief. 1.06. What is the ratio of the Value added (in %) of Algeria in 1969 to that in 1972?
Ensure brevity in your answer.  1.03. What is the ratio of the Value added (in %) of Chile in 1969 to that in 1972?
Offer a terse response. 1.02. What is the ratio of the Value added (in %) of Kenya in 1969 to that in 1972?
Your response must be concise. 0.9. What is the ratio of the Value added (in %) in United States in 1969 to that in 1972?
Give a very brief answer. 0.99. What is the ratio of the Value added (in %) in Algeria in 1969 to that in 1973?
Your answer should be compact. 0.98. What is the ratio of the Value added (in %) of Chile in 1969 to that in 1973?
Ensure brevity in your answer.  0.79. What is the ratio of the Value added (in %) in Kenya in 1969 to that in 1973?
Make the answer very short. 1.1. What is the ratio of the Value added (in %) in Chile in 1969 to that in 1974?
Give a very brief answer. 1.39. What is the ratio of the Value added (in %) in Kenya in 1969 to that in 1974?
Offer a terse response. 1.13. What is the ratio of the Value added (in %) in United States in 1969 to that in 1974?
Ensure brevity in your answer.  1.01. What is the ratio of the Value added (in %) in Algeria in 1970 to that in 1971?
Ensure brevity in your answer.  1.37. What is the ratio of the Value added (in %) of Chile in 1970 to that in 1971?
Provide a succinct answer. 0.87. What is the ratio of the Value added (in %) in Kenya in 1970 to that in 1971?
Offer a very short reply. 1.12. What is the ratio of the Value added (in %) in Algeria in 1970 to that in 1972?
Make the answer very short. 1.22. What is the ratio of the Value added (in %) of Chile in 1970 to that in 1972?
Keep it short and to the point. 0.81. What is the ratio of the Value added (in %) in Kenya in 1970 to that in 1972?
Keep it short and to the point. 0.96. What is the ratio of the Value added (in %) in United States in 1970 to that in 1972?
Provide a succinct answer. 0.92. What is the ratio of the Value added (in %) of Algeria in 1970 to that in 1973?
Your response must be concise. 1.16. What is the ratio of the Value added (in %) of Chile in 1970 to that in 1973?
Offer a very short reply. 0.63. What is the ratio of the Value added (in %) of Kenya in 1970 to that in 1973?
Your answer should be very brief. 1.17. What is the ratio of the Value added (in %) in United States in 1970 to that in 1973?
Ensure brevity in your answer.  0.9. What is the ratio of the Value added (in %) in Algeria in 1970 to that in 1974?
Offer a very short reply. 1.18. What is the ratio of the Value added (in %) of Chile in 1970 to that in 1974?
Your response must be concise. 1.1. What is the ratio of the Value added (in %) of Kenya in 1970 to that in 1974?
Your answer should be compact. 1.2. What is the ratio of the Value added (in %) of United States in 1970 to that in 1974?
Keep it short and to the point. 0.94. What is the ratio of the Value added (in %) in Algeria in 1971 to that in 1972?
Ensure brevity in your answer.  0.89. What is the ratio of the Value added (in %) of Chile in 1971 to that in 1972?
Keep it short and to the point. 0.93. What is the ratio of the Value added (in %) of Kenya in 1971 to that in 1972?
Ensure brevity in your answer.  0.86. What is the ratio of the Value added (in %) of United States in 1971 to that in 1972?
Make the answer very short. 0.93. What is the ratio of the Value added (in %) of Algeria in 1971 to that in 1973?
Provide a succinct answer. 0.85. What is the ratio of the Value added (in %) of Chile in 1971 to that in 1973?
Your answer should be very brief. 0.72. What is the ratio of the Value added (in %) of Kenya in 1971 to that in 1973?
Provide a short and direct response. 1.05. What is the ratio of the Value added (in %) of United States in 1971 to that in 1973?
Offer a very short reply. 0.9. What is the ratio of the Value added (in %) in Algeria in 1971 to that in 1974?
Offer a terse response. 0.86. What is the ratio of the Value added (in %) of Chile in 1971 to that in 1974?
Keep it short and to the point. 1.27. What is the ratio of the Value added (in %) of Kenya in 1971 to that in 1974?
Offer a very short reply. 1.08. What is the ratio of the Value added (in %) in United States in 1971 to that in 1974?
Your answer should be very brief. 0.95. What is the ratio of the Value added (in %) of Algeria in 1972 to that in 1973?
Provide a succinct answer. 0.95. What is the ratio of the Value added (in %) in Chile in 1972 to that in 1973?
Make the answer very short. 0.77. What is the ratio of the Value added (in %) in Kenya in 1972 to that in 1973?
Provide a succinct answer. 1.22. What is the ratio of the Value added (in %) of United States in 1972 to that in 1973?
Provide a succinct answer. 0.98. What is the ratio of the Value added (in %) in Algeria in 1972 to that in 1974?
Your answer should be very brief. 0.97. What is the ratio of the Value added (in %) in Chile in 1972 to that in 1974?
Give a very brief answer. 1.36. What is the ratio of the Value added (in %) in Kenya in 1972 to that in 1974?
Make the answer very short. 1.25. What is the ratio of the Value added (in %) in United States in 1972 to that in 1974?
Your response must be concise. 1.02. What is the ratio of the Value added (in %) in Chile in 1973 to that in 1974?
Provide a succinct answer. 1.75. What is the ratio of the Value added (in %) of Kenya in 1973 to that in 1974?
Provide a succinct answer. 1.03. What is the ratio of the Value added (in %) in United States in 1973 to that in 1974?
Make the answer very short. 1.05. What is the difference between the highest and the second highest Value added (in %) in Algeria?
Your answer should be compact. 0.83. What is the difference between the highest and the second highest Value added (in %) in Chile?
Your response must be concise. 1.47. What is the difference between the highest and the second highest Value added (in %) of Kenya?
Your answer should be very brief. 0.27. What is the difference between the highest and the second highest Value added (in %) in United States?
Your response must be concise. 0.58. What is the difference between the highest and the lowest Value added (in %) in Algeria?
Keep it short and to the point. 2.2. What is the difference between the highest and the lowest Value added (in %) in Chile?
Ensure brevity in your answer.  5.25. What is the difference between the highest and the lowest Value added (in %) in Kenya?
Keep it short and to the point. 2.34. What is the difference between the highest and the lowest Value added (in %) in United States?
Provide a short and direct response. 2.34. 